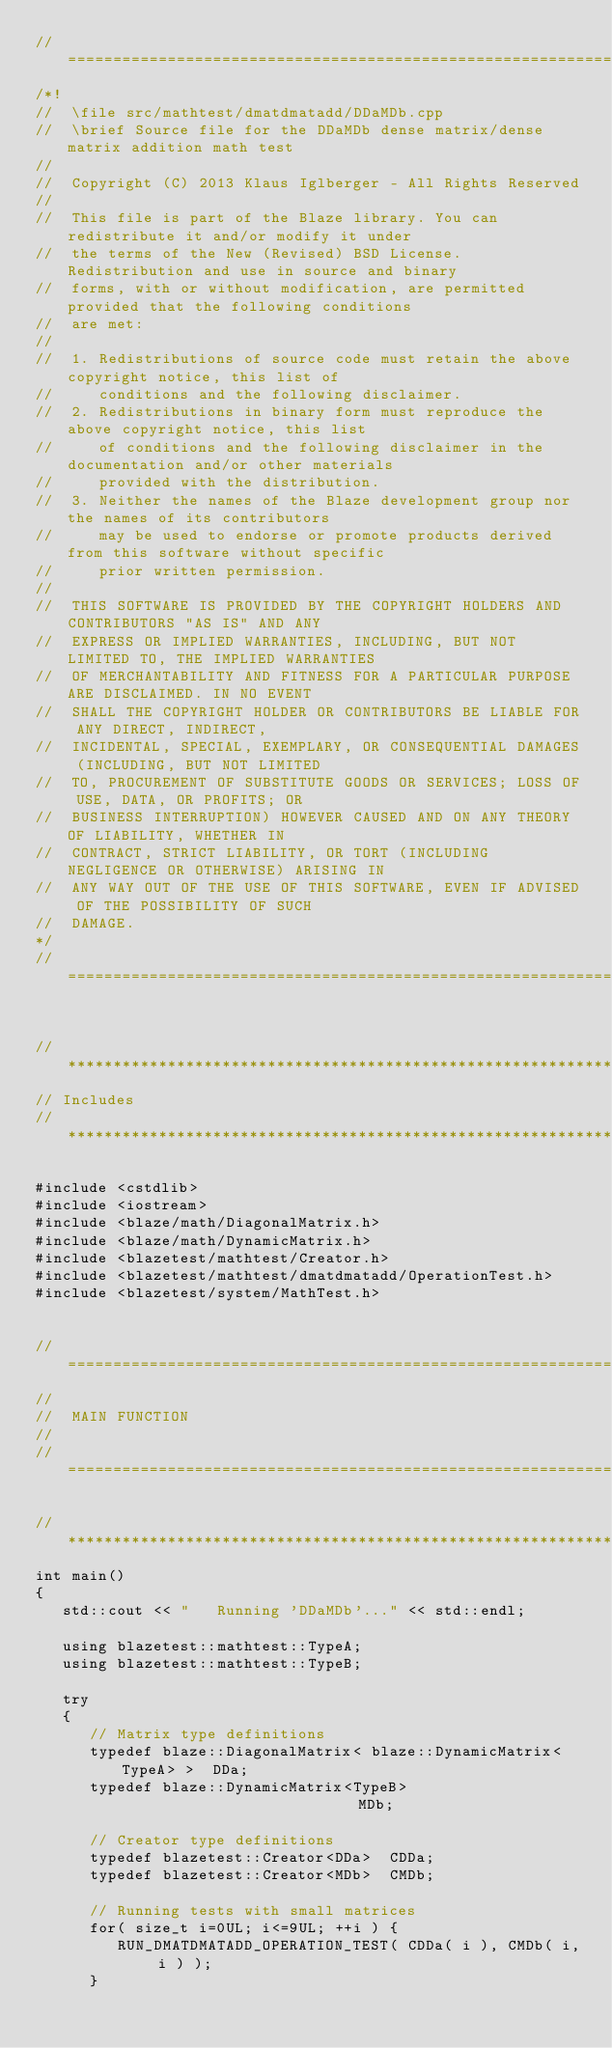Convert code to text. <code><loc_0><loc_0><loc_500><loc_500><_C++_>//=================================================================================================
/*!
//  \file src/mathtest/dmatdmatadd/DDaMDb.cpp
//  \brief Source file for the DDaMDb dense matrix/dense matrix addition math test
//
//  Copyright (C) 2013 Klaus Iglberger - All Rights Reserved
//
//  This file is part of the Blaze library. You can redistribute it and/or modify it under
//  the terms of the New (Revised) BSD License. Redistribution and use in source and binary
//  forms, with or without modification, are permitted provided that the following conditions
//  are met:
//
//  1. Redistributions of source code must retain the above copyright notice, this list of
//     conditions and the following disclaimer.
//  2. Redistributions in binary form must reproduce the above copyright notice, this list
//     of conditions and the following disclaimer in the documentation and/or other materials
//     provided with the distribution.
//  3. Neither the names of the Blaze development group nor the names of its contributors
//     may be used to endorse or promote products derived from this software without specific
//     prior written permission.
//
//  THIS SOFTWARE IS PROVIDED BY THE COPYRIGHT HOLDERS AND CONTRIBUTORS "AS IS" AND ANY
//  EXPRESS OR IMPLIED WARRANTIES, INCLUDING, BUT NOT LIMITED TO, THE IMPLIED WARRANTIES
//  OF MERCHANTABILITY AND FITNESS FOR A PARTICULAR PURPOSE ARE DISCLAIMED. IN NO EVENT
//  SHALL THE COPYRIGHT HOLDER OR CONTRIBUTORS BE LIABLE FOR ANY DIRECT, INDIRECT,
//  INCIDENTAL, SPECIAL, EXEMPLARY, OR CONSEQUENTIAL DAMAGES (INCLUDING, BUT NOT LIMITED
//  TO, PROCUREMENT OF SUBSTITUTE GOODS OR SERVICES; LOSS OF USE, DATA, OR PROFITS; OR
//  BUSINESS INTERRUPTION) HOWEVER CAUSED AND ON ANY THEORY OF LIABILITY, WHETHER IN
//  CONTRACT, STRICT LIABILITY, OR TORT (INCLUDING NEGLIGENCE OR OTHERWISE) ARISING IN
//  ANY WAY OUT OF THE USE OF THIS SOFTWARE, EVEN IF ADVISED OF THE POSSIBILITY OF SUCH
//  DAMAGE.
*/
//=================================================================================================


//*************************************************************************************************
// Includes
//*************************************************************************************************

#include <cstdlib>
#include <iostream>
#include <blaze/math/DiagonalMatrix.h>
#include <blaze/math/DynamicMatrix.h>
#include <blazetest/mathtest/Creator.h>
#include <blazetest/mathtest/dmatdmatadd/OperationTest.h>
#include <blazetest/system/MathTest.h>


//=================================================================================================
//
//  MAIN FUNCTION
//
//=================================================================================================

//*************************************************************************************************
int main()
{
   std::cout << "   Running 'DDaMDb'..." << std::endl;

   using blazetest::mathtest::TypeA;
   using blazetest::mathtest::TypeB;

   try
   {
      // Matrix type definitions
      typedef blaze::DiagonalMatrix< blaze::DynamicMatrix<TypeA> >  DDa;
      typedef blaze::DynamicMatrix<TypeB>                           MDb;

      // Creator type definitions
      typedef blazetest::Creator<DDa>  CDDa;
      typedef blazetest::Creator<MDb>  CMDb;

      // Running tests with small matrices
      for( size_t i=0UL; i<=9UL; ++i ) {
         RUN_DMATDMATADD_OPERATION_TEST( CDDa( i ), CMDb( i, i ) );
      }
</code> 